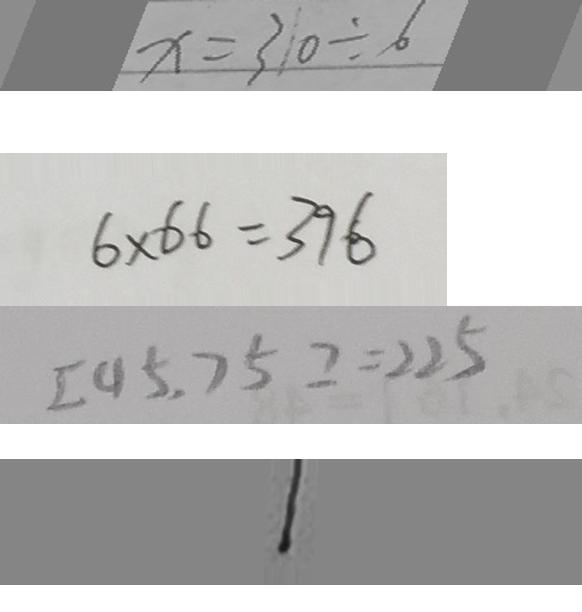Convert formula to latex. <formula><loc_0><loc_0><loc_500><loc_500>x = 3 1 0 \div 6 
 6 \times 6 6 = 3 9 6 
 [ 4 5 , 7 5 ] = 2 2 5 
 1</formula> 